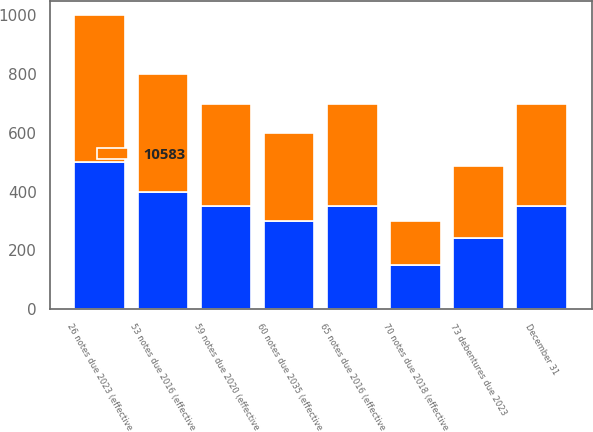Convert chart. <chart><loc_0><loc_0><loc_500><loc_500><stacked_bar_chart><ecel><fcel>December 31<fcel>53 notes due 2016 (effective<fcel>26 notes due 2023 (effective<fcel>60 notes due 2035 (effective<fcel>65 notes due 2016 (effective<fcel>70 notes due 2018 (effective<fcel>59 notes due 2020 (effective<fcel>73 debentures due 2023<nl><fcel>nan<fcel>350<fcel>400<fcel>500<fcel>300<fcel>350<fcel>150<fcel>350<fcel>243<nl><fcel>10583<fcel>350<fcel>400<fcel>500<fcel>300<fcel>350<fcel>150<fcel>350<fcel>243<nl></chart> 